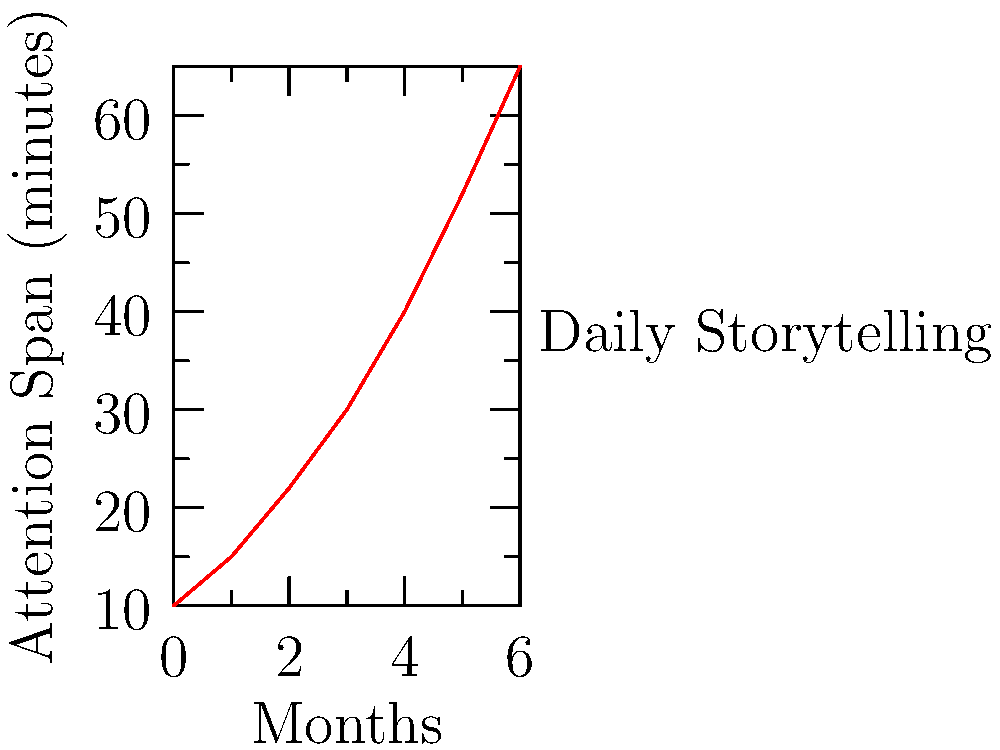Based on the time series graph showing the effect of daily storytelling on children's attention span over a 6-month period, what is the approximate percentage increase in attention span from the start to the end of the study? To calculate the percentage increase in attention span, we need to follow these steps:

1. Identify the initial attention span: At month 0, the attention span is 10 minutes.

2. Identify the final attention span: At month 6, the attention span is 65 minutes.

3. Calculate the absolute increase:
   $65 - 10 = 55$ minutes

4. Calculate the percentage increase using the formula:
   Percentage increase = $\frac{\text{Increase}}{\text{Original Value}} \times 100\%$

   $\frac{55}{10} \times 100\% = 5.5 \times 100\% = 550\%$

Therefore, the percentage increase in attention span from the start to the end of the 6-month study is approximately 550%.
Answer: 550% 